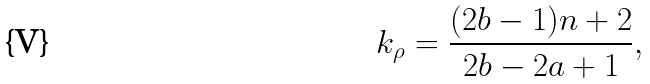<formula> <loc_0><loc_0><loc_500><loc_500>k _ { \rho } = \frac { ( 2 b - 1 ) n + 2 } { 2 b - 2 a + 1 } ,</formula> 